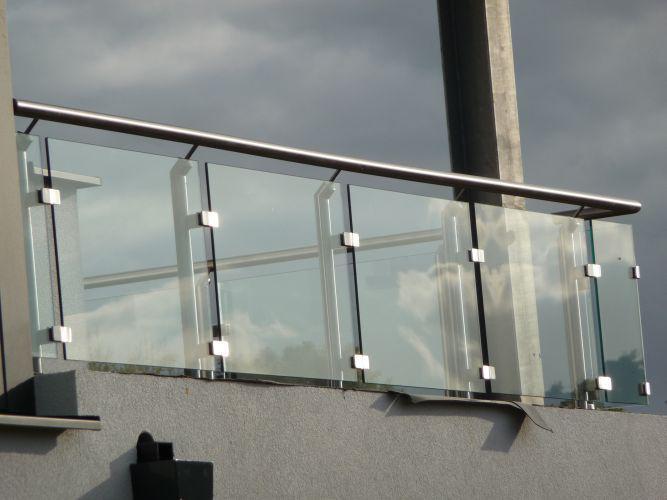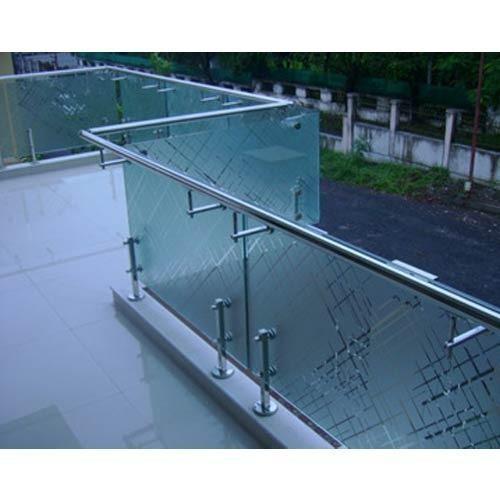The first image is the image on the left, the second image is the image on the right. Examine the images to the left and right. Is the description "there is a wooden deck with glass surrounding it, overlooking the water" accurate? Answer yes or no. No. The first image is the image on the left, the second image is the image on the right. Evaluate the accuracy of this statement regarding the images: "In one image, a glass-paneled balcony with a 'plank' floor overlooks the ocean on the right.". Is it true? Answer yes or no. No. 